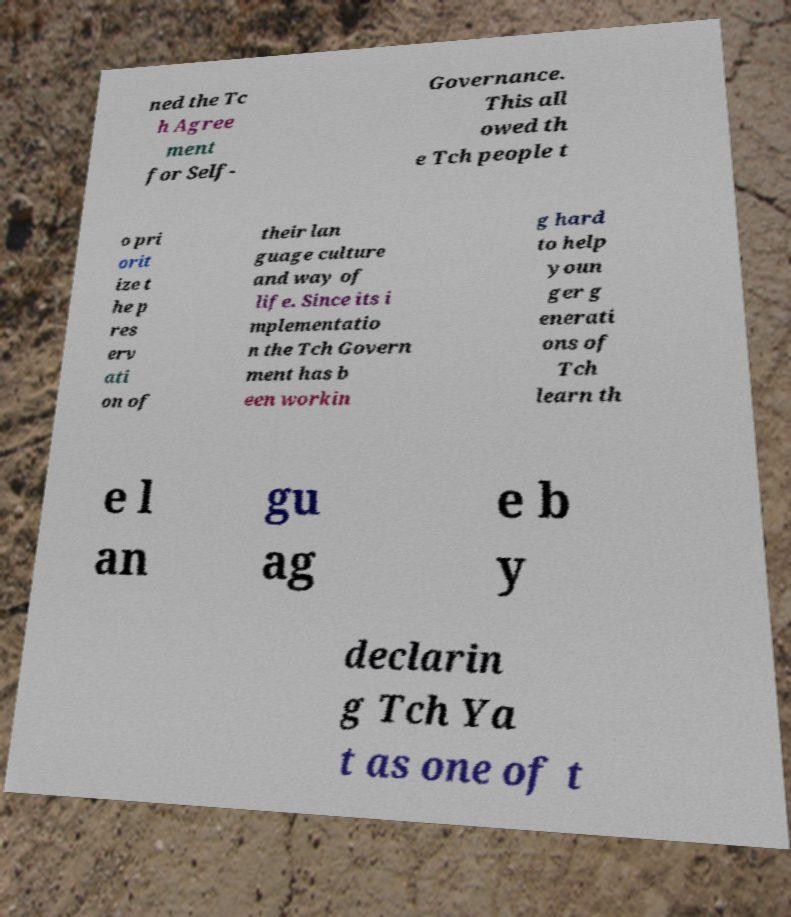Could you assist in decoding the text presented in this image and type it out clearly? ned the Tc h Agree ment for Self- Governance. This all owed th e Tch people t o pri orit ize t he p res erv ati on of their lan guage culture and way of life. Since its i mplementatio n the Tch Govern ment has b een workin g hard to help youn ger g enerati ons of Tch learn th e l an gu ag e b y declarin g Tch Ya t as one of t 